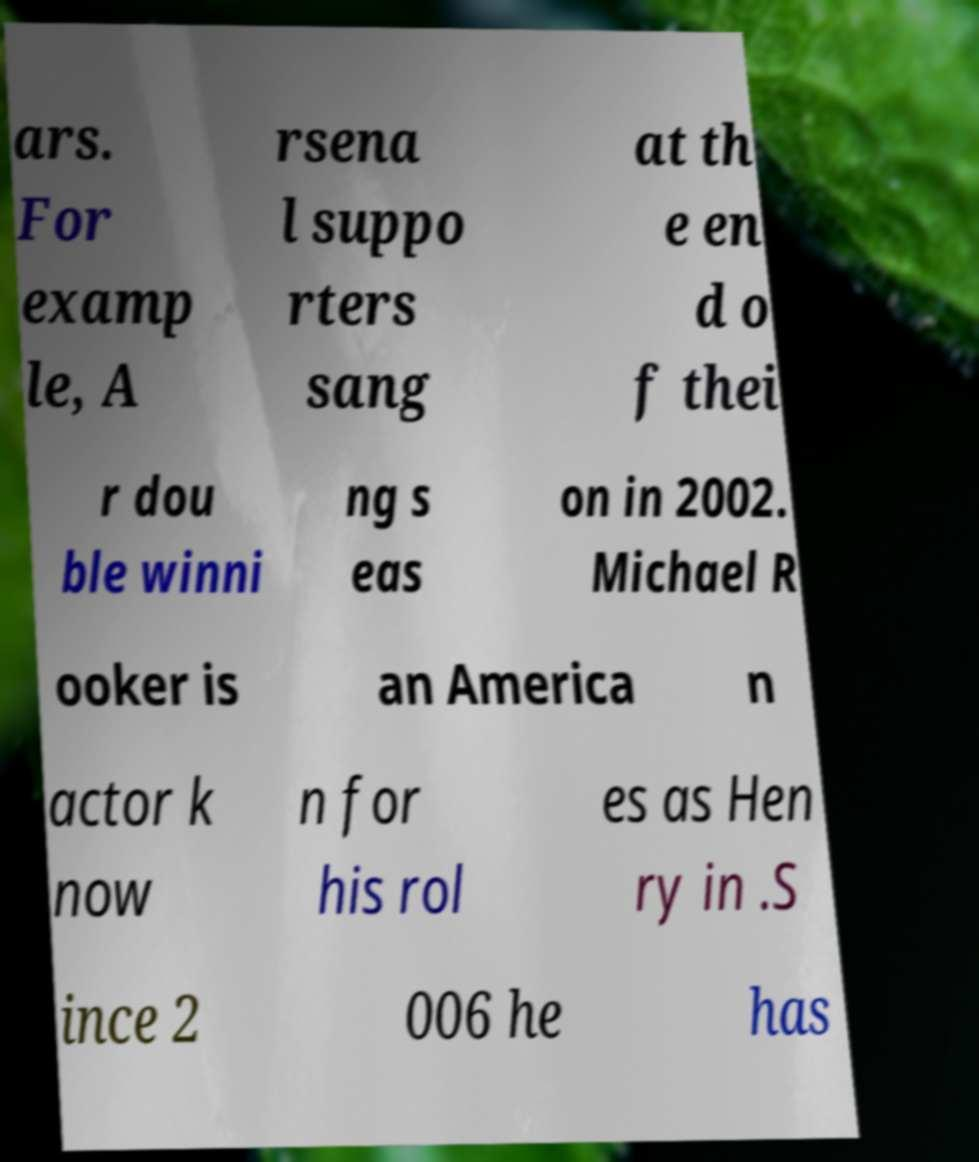There's text embedded in this image that I need extracted. Can you transcribe it verbatim? ars. For examp le, A rsena l suppo rters sang at th e en d o f thei r dou ble winni ng s eas on in 2002. Michael R ooker is an America n actor k now n for his rol es as Hen ry in .S ince 2 006 he has 